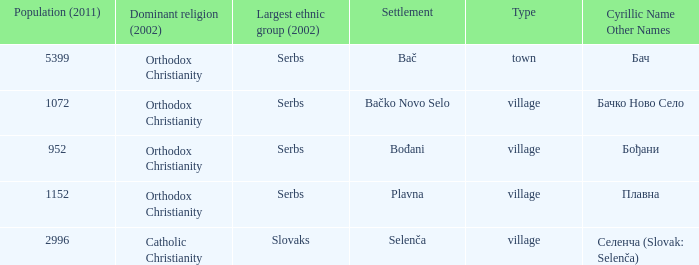What is the second way of writting плавна. Plavna. 